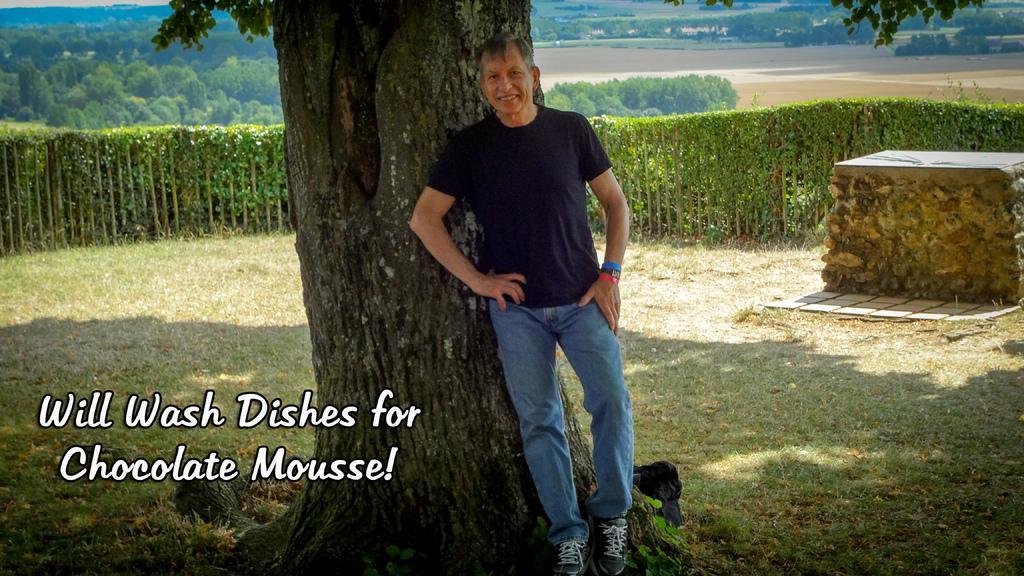Can you describe this image briefly? In this image we can see a person is standing near a tree. On the bottom left side of the image we can see a text. On the right side of the image we can see rocks. 